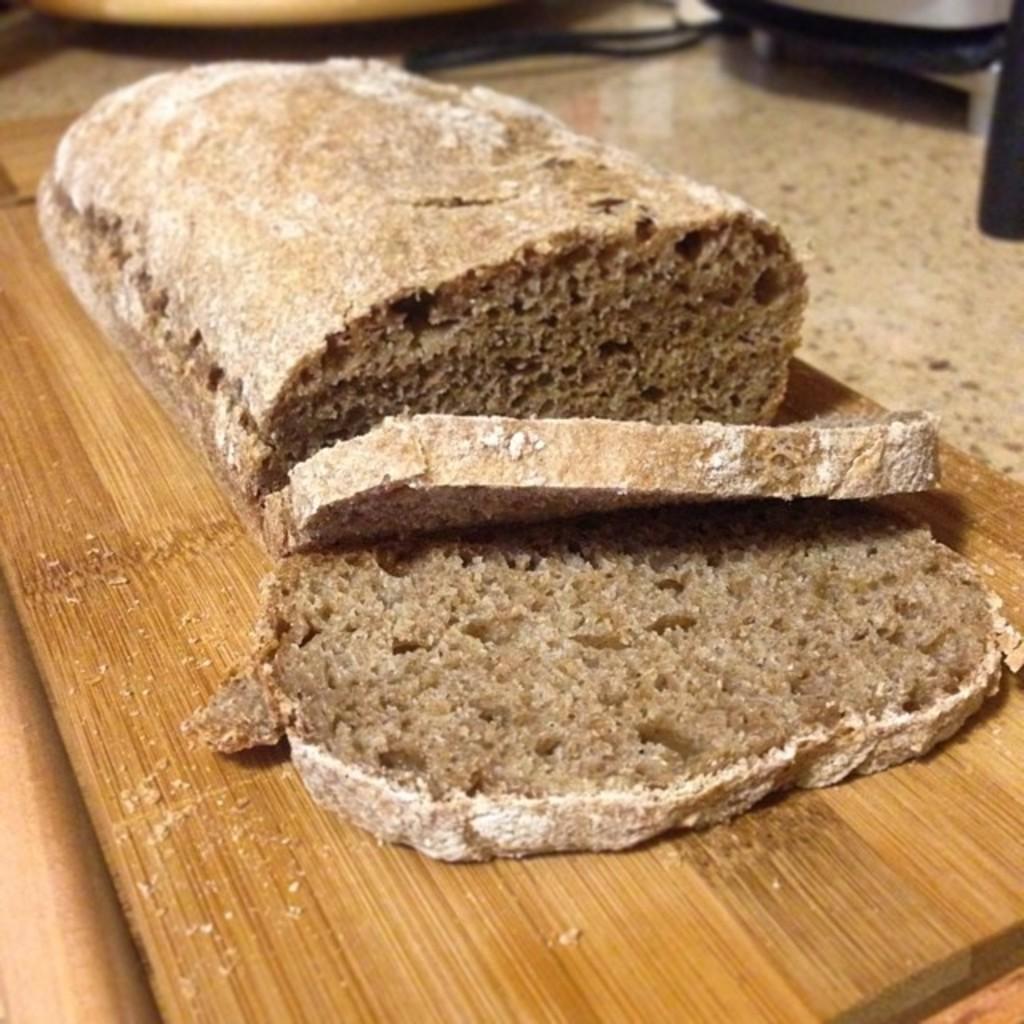Could you give a brief overview of what you see in this image? In this picture we can see some food on a wooden plank. There are few vessels in the background. 